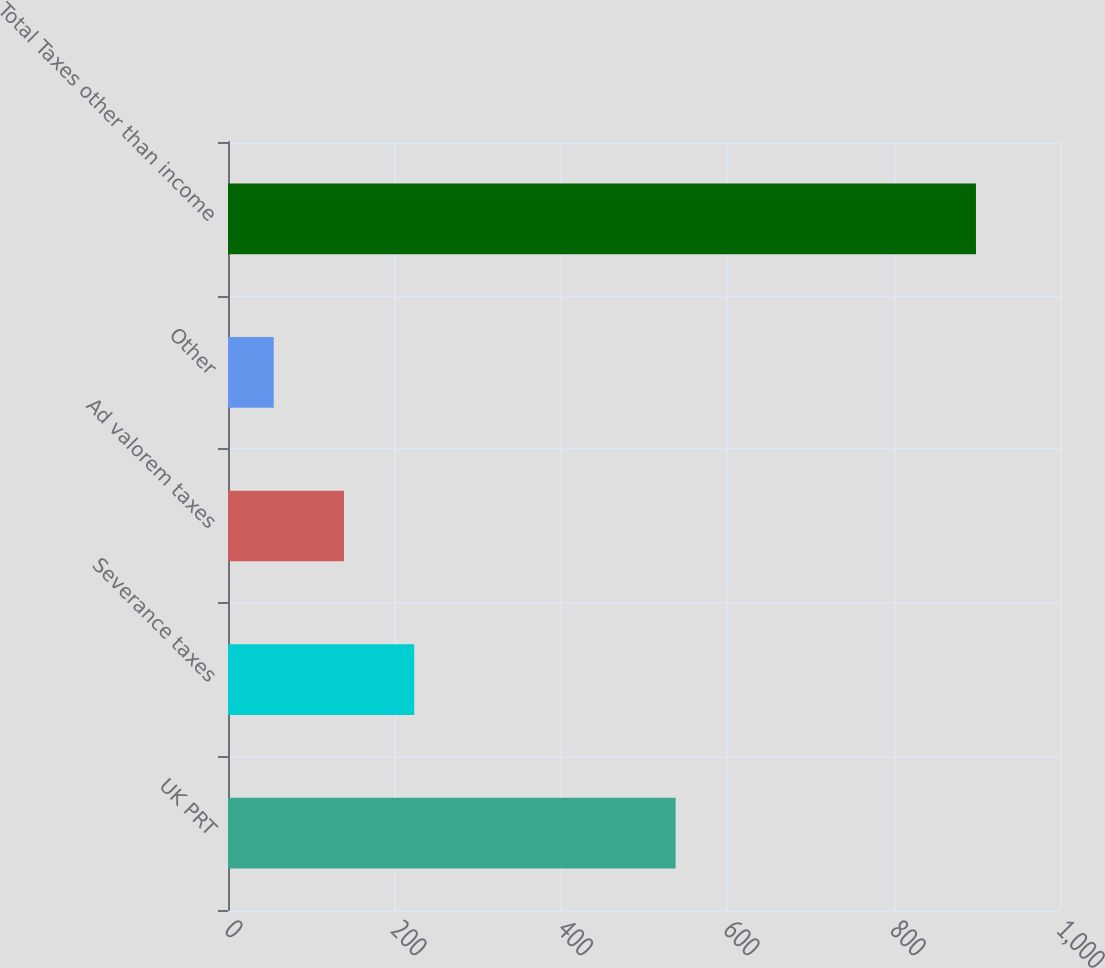<chart> <loc_0><loc_0><loc_500><loc_500><bar_chart><fcel>UK PRT<fcel>Severance taxes<fcel>Ad valorem taxes<fcel>Other<fcel>Total Taxes other than income<nl><fcel>538<fcel>223.8<fcel>139.4<fcel>55<fcel>899<nl></chart> 